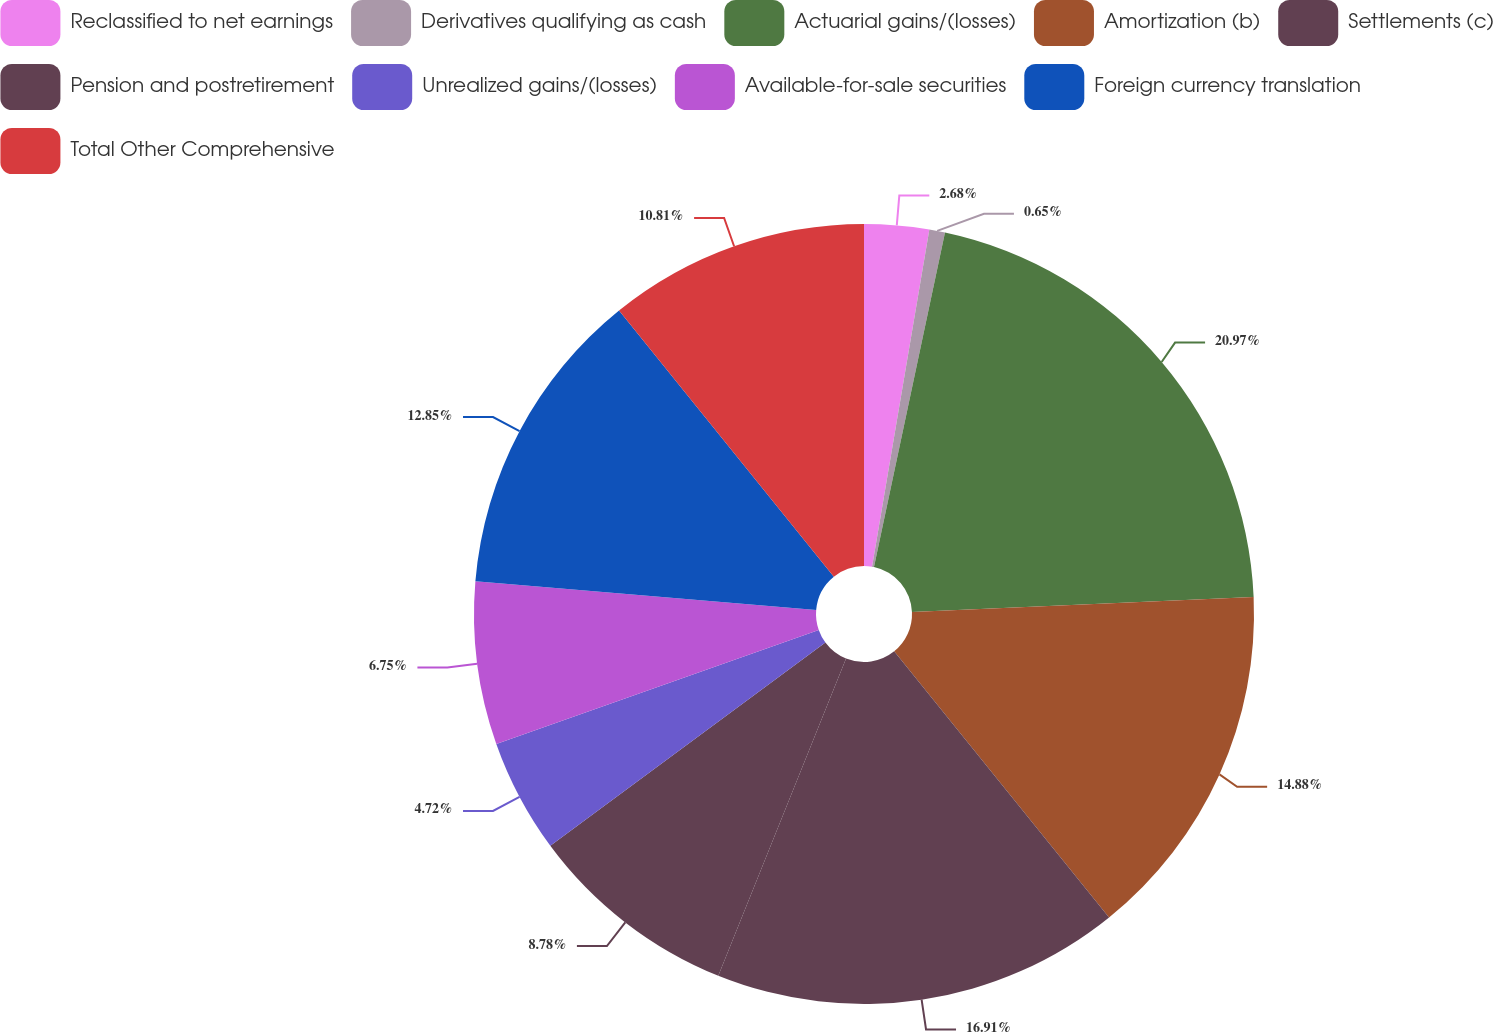Convert chart to OTSL. <chart><loc_0><loc_0><loc_500><loc_500><pie_chart><fcel>Reclassified to net earnings<fcel>Derivatives qualifying as cash<fcel>Actuarial gains/(losses)<fcel>Amortization (b)<fcel>Settlements (c)<fcel>Pension and postretirement<fcel>Unrealized gains/(losses)<fcel>Available-for-sale securities<fcel>Foreign currency translation<fcel>Total Other Comprehensive<nl><fcel>2.68%<fcel>0.65%<fcel>20.98%<fcel>14.88%<fcel>16.91%<fcel>8.78%<fcel>4.72%<fcel>6.75%<fcel>12.85%<fcel>10.81%<nl></chart> 